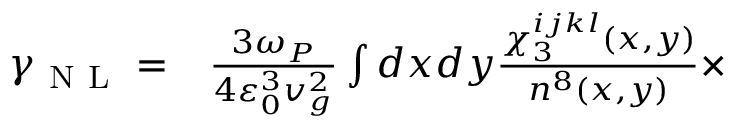<formula> <loc_0><loc_0><loc_500><loc_500>\begin{array} { r l } { \gamma _ { N L } = } & \frac { 3 \omega _ { P } } { 4 \varepsilon _ { 0 } ^ { 3 } v _ { g } ^ { 2 } } \int d x d y \frac { \chi _ { 3 } ^ { i j k l } ( x , y ) } { n ^ { 8 } ( x , y ) } \times } \end{array}</formula> 